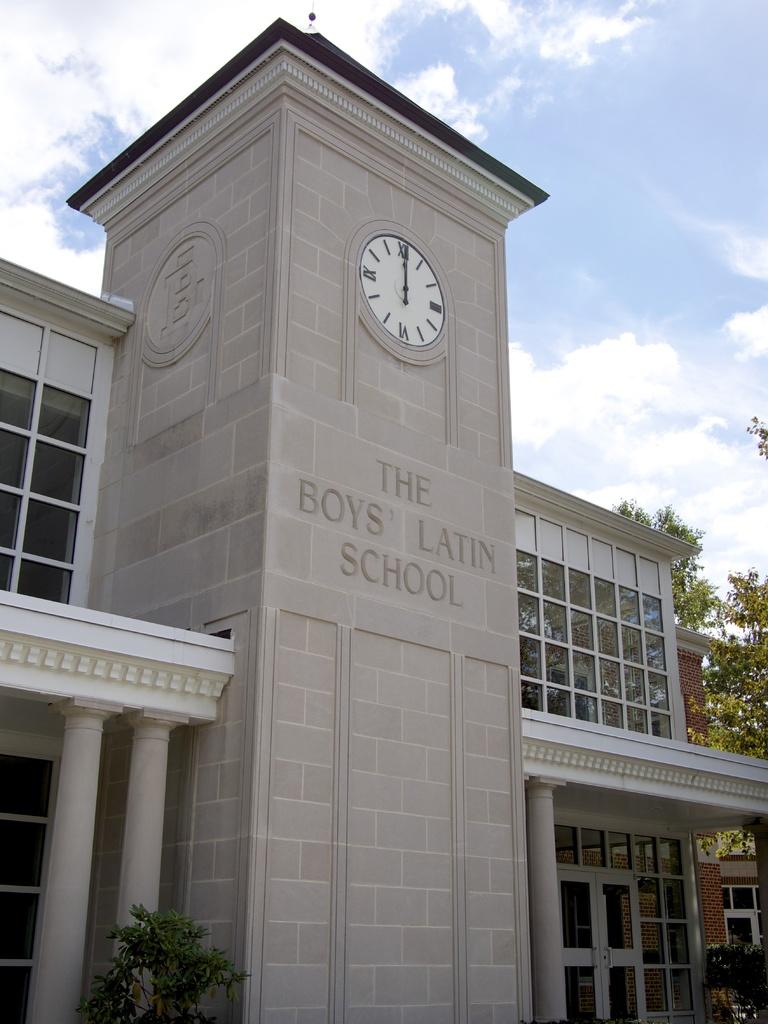What is the name of this school?
Your response must be concise. The boys latin school. What time is it?
Make the answer very short. 12:00. 